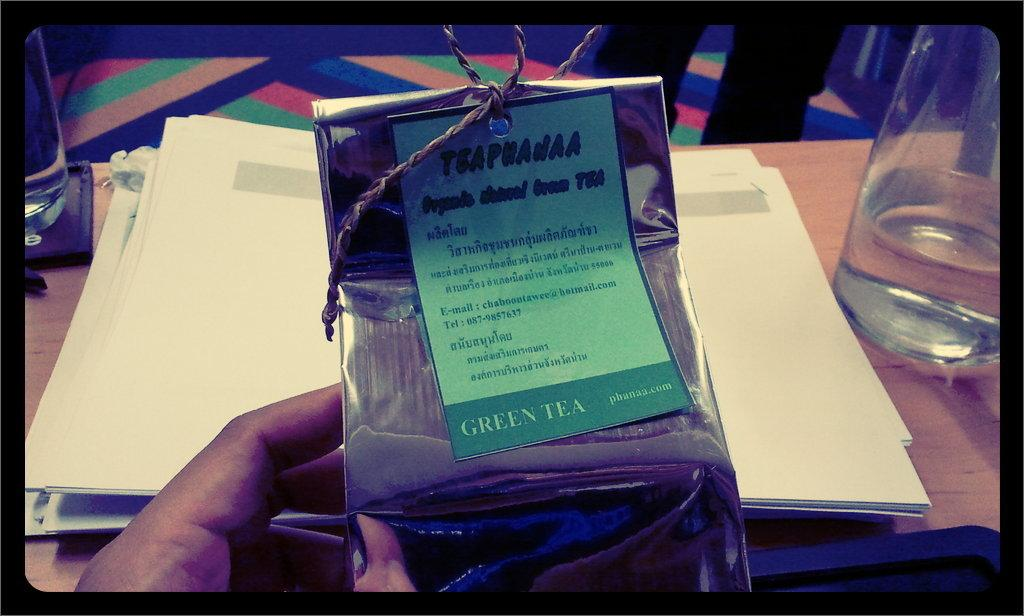Provide a one-sentence caption for the provided image. A person is holding a package with a label that says Green Tea. 